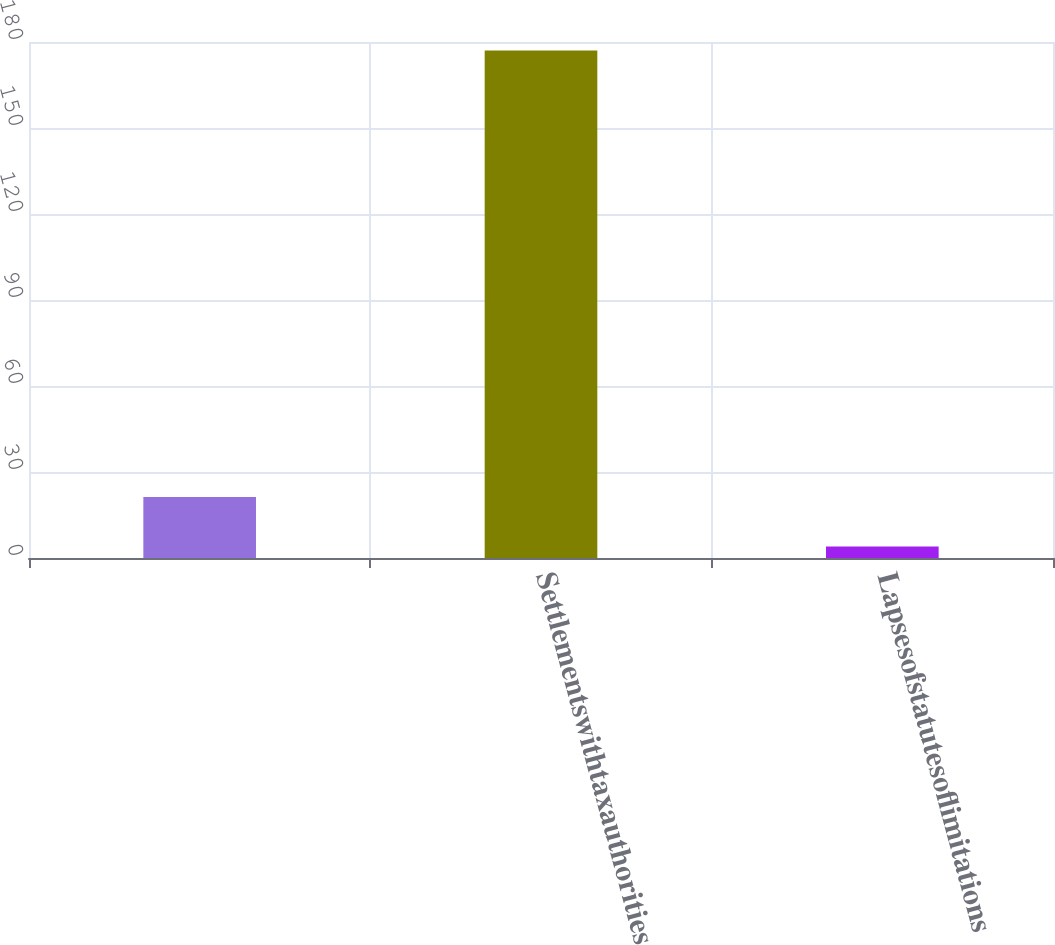<chart> <loc_0><loc_0><loc_500><loc_500><bar_chart><ecel><fcel>Settlementswithtaxauthorities<fcel>Lapsesofstatutesoflimitations<nl><fcel>21.3<fcel>177<fcel>4<nl></chart> 